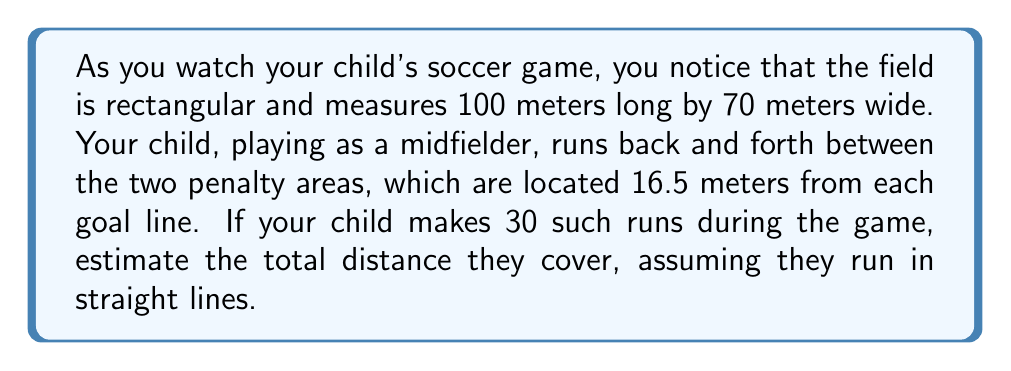Teach me how to tackle this problem. Let's break this problem down step-by-step:

1. First, we need to calculate the distance of one run:
   
   [asy]
   size(200,100);
   draw((0,0)--(100,0)--(100,70)--(0,70)--cycle);
   draw((16.5,0)--(16.5,70),dashed);
   draw((83.5,0)--(83.5,70),dashed);
   label("100 m", (50,-5));
   label("70 m", (-5,35), W);
   label("16.5 m", (8.25,-5));
   label("67 m", (50,35));
   [/asy]

2. The distance between the two penalty areas is:
   $$ 100 - (16.5 \times 2) = 67 \text{ meters} $$

3. We can use the Pythagorean theorem to calculate the diagonal distance:
   $$ \text{diagonal} = \sqrt{67^2 + 70^2} $$

4. Let's calculate this:
   $$ \sqrt{67^2 + 70^2} = \sqrt{4489 + 4900} = \sqrt{9389} \approx 96.9 \text{ meters} $$

5. Now, for 30 runs, the total distance would be:
   $$ 30 \times 96.9 = 2907 \text{ meters} $$

6. Rounding to a reasonable estimate:
   $$ 2907 \text{ meters} \approx 2900 \text{ meters} = 2.9 \text{ kilometers} $$
Answer: The estimated total distance covered by your child during the game is approximately 2.9 kilometers. 